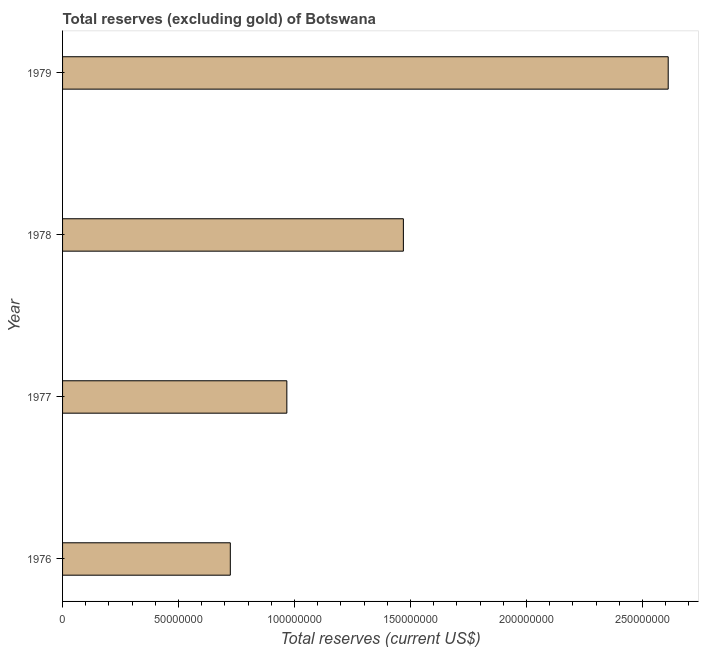Does the graph contain any zero values?
Provide a succinct answer. No. What is the title of the graph?
Ensure brevity in your answer.  Total reserves (excluding gold) of Botswana. What is the label or title of the X-axis?
Make the answer very short. Total reserves (current US$). What is the label or title of the Y-axis?
Give a very brief answer. Year. What is the total reserves (excluding gold) in 1978?
Your answer should be compact. 1.47e+08. Across all years, what is the maximum total reserves (excluding gold)?
Ensure brevity in your answer.  2.61e+08. Across all years, what is the minimum total reserves (excluding gold)?
Ensure brevity in your answer.  7.23e+07. In which year was the total reserves (excluding gold) maximum?
Offer a terse response. 1979. In which year was the total reserves (excluding gold) minimum?
Make the answer very short. 1976. What is the sum of the total reserves (excluding gold)?
Provide a succinct answer. 5.77e+08. What is the difference between the total reserves (excluding gold) in 1977 and 1979?
Offer a terse response. -1.64e+08. What is the average total reserves (excluding gold) per year?
Your response must be concise. 1.44e+08. What is the median total reserves (excluding gold)?
Provide a succinct answer. 1.22e+08. What is the ratio of the total reserves (excluding gold) in 1978 to that in 1979?
Your answer should be very brief. 0.56. Is the total reserves (excluding gold) in 1977 less than that in 1979?
Your answer should be compact. Yes. Is the difference between the total reserves (excluding gold) in 1977 and 1979 greater than the difference between any two years?
Your response must be concise. No. What is the difference between the highest and the second highest total reserves (excluding gold)?
Provide a succinct answer. 1.14e+08. Is the sum of the total reserves (excluding gold) in 1978 and 1979 greater than the maximum total reserves (excluding gold) across all years?
Make the answer very short. Yes. What is the difference between the highest and the lowest total reserves (excluding gold)?
Make the answer very short. 1.89e+08. In how many years, is the total reserves (excluding gold) greater than the average total reserves (excluding gold) taken over all years?
Your answer should be compact. 2. How many bars are there?
Your response must be concise. 4. Are all the bars in the graph horizontal?
Ensure brevity in your answer.  Yes. How many years are there in the graph?
Offer a terse response. 4. Are the values on the major ticks of X-axis written in scientific E-notation?
Keep it short and to the point. No. What is the Total reserves (current US$) in 1976?
Provide a succinct answer. 7.23e+07. What is the Total reserves (current US$) of 1977?
Provide a short and direct response. 9.67e+07. What is the Total reserves (current US$) of 1978?
Provide a short and direct response. 1.47e+08. What is the Total reserves (current US$) in 1979?
Provide a succinct answer. 2.61e+08. What is the difference between the Total reserves (current US$) in 1976 and 1977?
Keep it short and to the point. -2.44e+07. What is the difference between the Total reserves (current US$) in 1976 and 1978?
Provide a short and direct response. -7.46e+07. What is the difference between the Total reserves (current US$) in 1976 and 1979?
Provide a succinct answer. -1.89e+08. What is the difference between the Total reserves (current US$) in 1977 and 1978?
Give a very brief answer. -5.02e+07. What is the difference between the Total reserves (current US$) in 1977 and 1979?
Offer a very short reply. -1.64e+08. What is the difference between the Total reserves (current US$) in 1978 and 1979?
Offer a very short reply. -1.14e+08. What is the ratio of the Total reserves (current US$) in 1976 to that in 1977?
Offer a very short reply. 0.75. What is the ratio of the Total reserves (current US$) in 1976 to that in 1978?
Ensure brevity in your answer.  0.49. What is the ratio of the Total reserves (current US$) in 1976 to that in 1979?
Make the answer very short. 0.28. What is the ratio of the Total reserves (current US$) in 1977 to that in 1978?
Ensure brevity in your answer.  0.66. What is the ratio of the Total reserves (current US$) in 1977 to that in 1979?
Give a very brief answer. 0.37. What is the ratio of the Total reserves (current US$) in 1978 to that in 1979?
Your answer should be very brief. 0.56. 